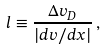<formula> <loc_0><loc_0><loc_500><loc_500>l \equiv \frac { \Delta v _ { D } } { | d v / d x | } \, ,</formula> 